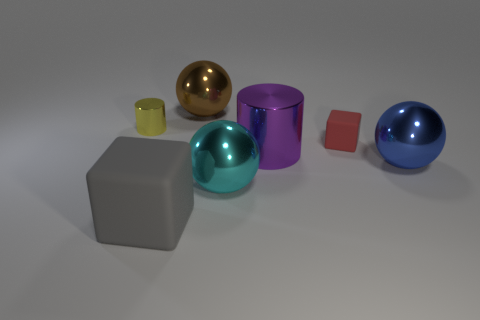Add 3 tiny gray blocks. How many objects exist? 10 Subtract all balls. How many objects are left? 4 Add 6 big yellow metallic cylinders. How many big yellow metallic cylinders exist? 6 Subtract 0 blue cylinders. How many objects are left? 7 Subtract all large green things. Subtract all large purple objects. How many objects are left? 6 Add 2 cyan things. How many cyan things are left? 3 